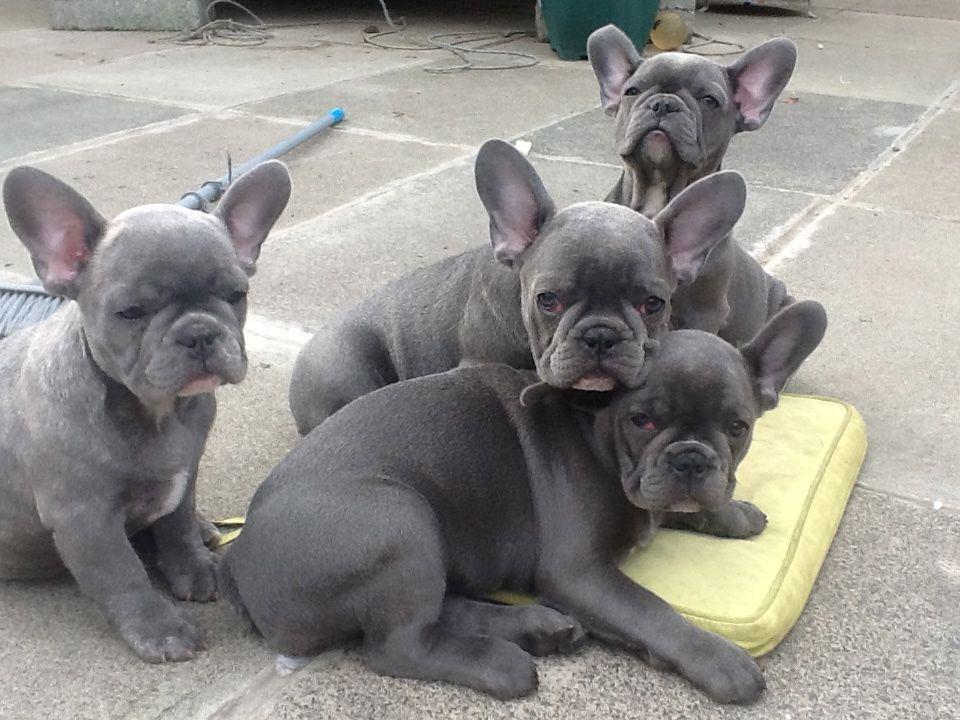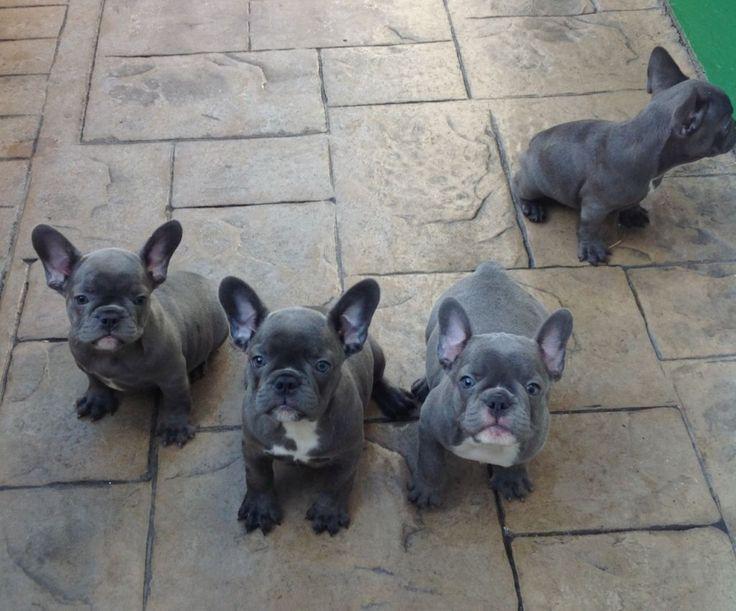The first image is the image on the left, the second image is the image on the right. Given the left and right images, does the statement "Two dogs are relaxing on the ground." hold true? Answer yes or no. No. The first image is the image on the left, the second image is the image on the right. Examine the images to the left and right. Is the description "An image shows exactly one gray big-eared dog, and it is wearing something." accurate? Answer yes or no. No. 